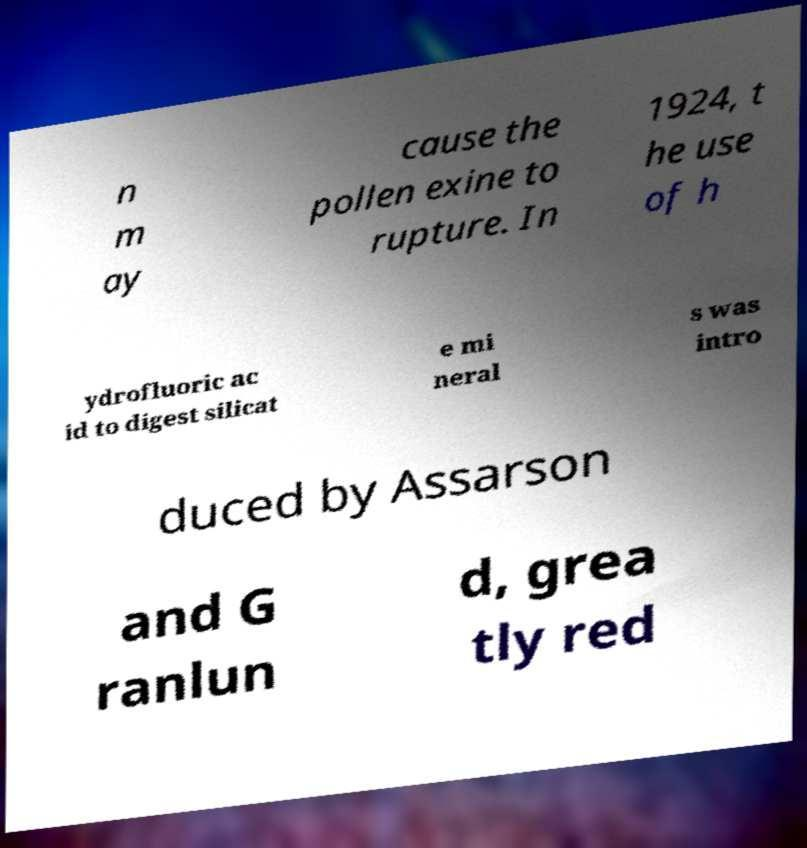What messages or text are displayed in this image? I need them in a readable, typed format. n m ay cause the pollen exine to rupture. In 1924, t he use of h ydrofluoric ac id to digest silicat e mi neral s was intro duced by Assarson and G ranlun d, grea tly red 